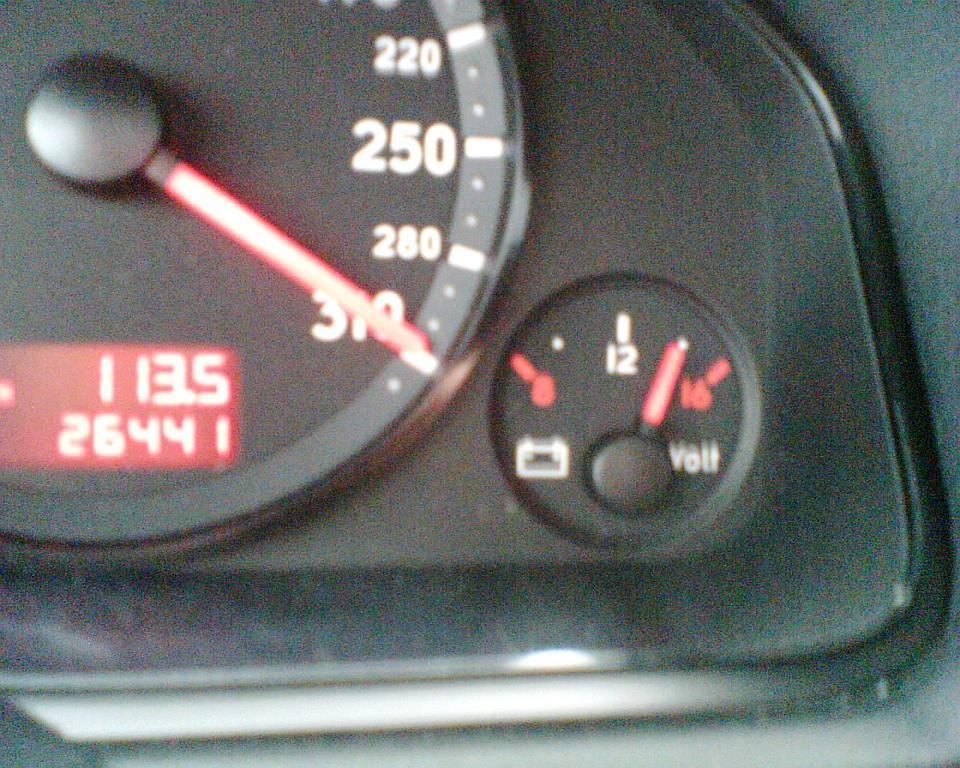In one or two sentences, can you explain what this image depicts? In these pictures we can see gauges. These are pointers. Background it is in black color. 